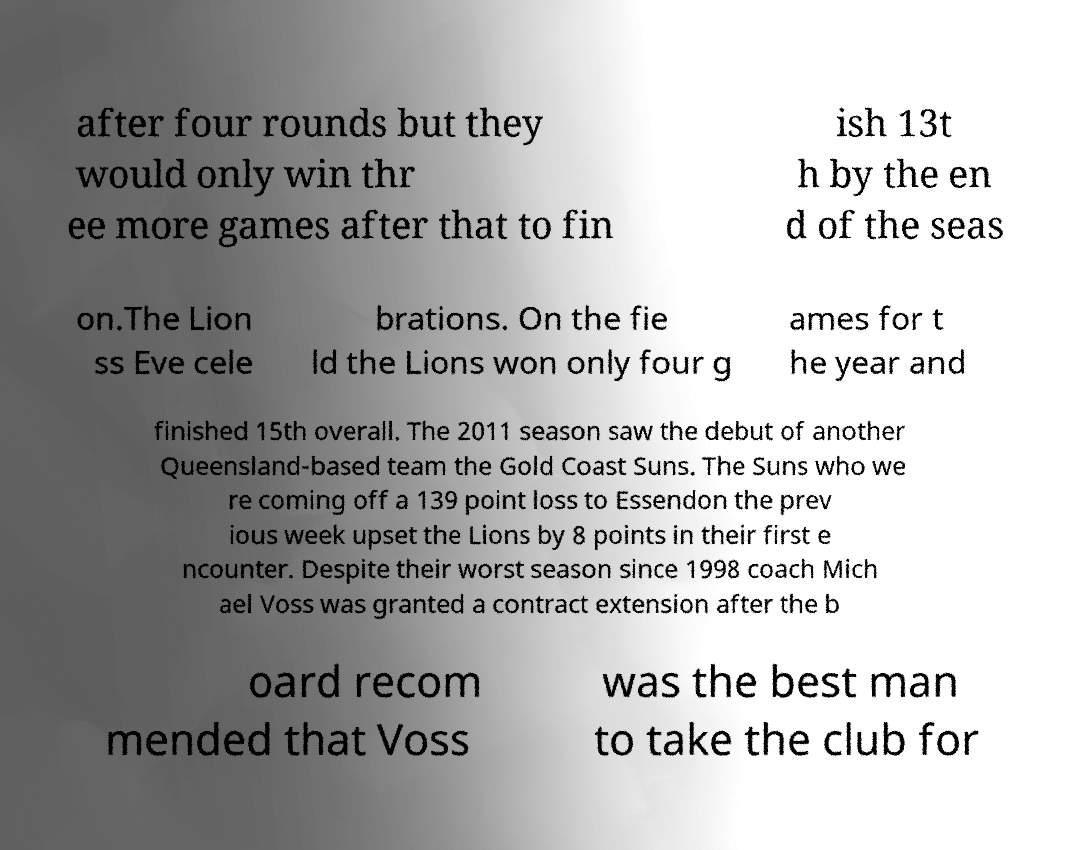For documentation purposes, I need the text within this image transcribed. Could you provide that? after four rounds but they would only win thr ee more games after that to fin ish 13t h by the en d of the seas on.The Lion ss Eve cele brations. On the fie ld the Lions won only four g ames for t he year and finished 15th overall. The 2011 season saw the debut of another Queensland-based team the Gold Coast Suns. The Suns who we re coming off a 139 point loss to Essendon the prev ious week upset the Lions by 8 points in their first e ncounter. Despite their worst season since 1998 coach Mich ael Voss was granted a contract extension after the b oard recom mended that Voss was the best man to take the club for 